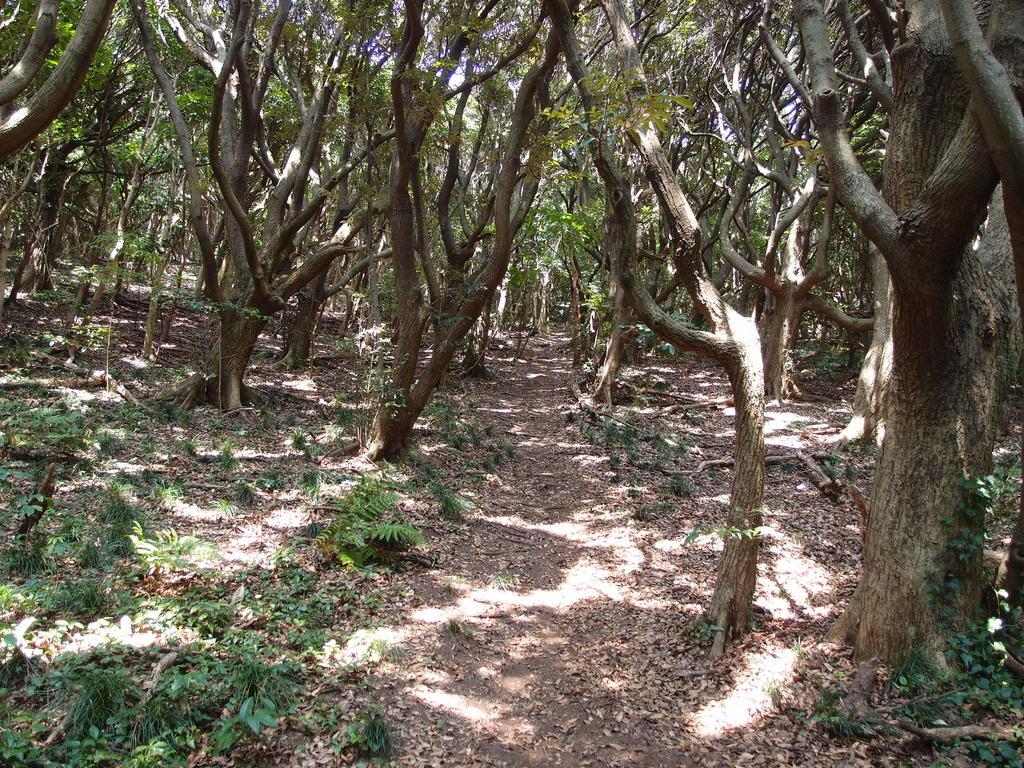What type of environment is shown in the image? The image appears to depict a forest. What can be seen on the ground in the image? There are plants on the ground in the image. How many trees are visible in the image? There are many trees in the image. What type of polish is being applied to the trees in the image? There is no indication in the image that any polish is being applied to the trees. 